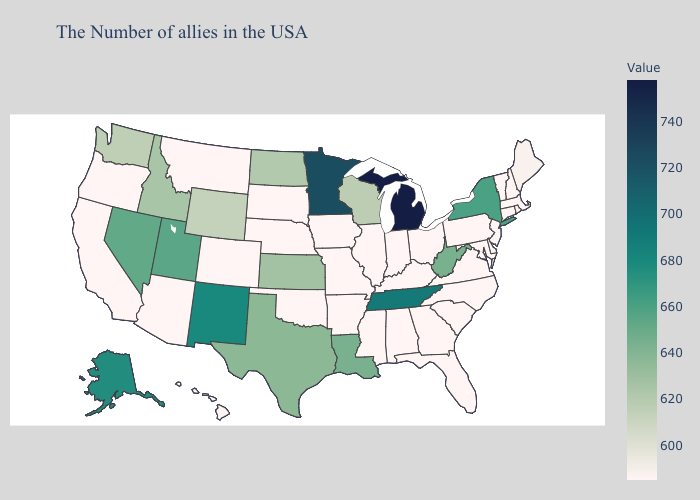Does Oregon have the lowest value in the USA?
Quick response, please. Yes. Does Tennessee have the highest value in the USA?
Give a very brief answer. No. Among the states that border Nevada , does Idaho have the highest value?
Concise answer only. No. Does Michigan have the highest value in the MidWest?
Concise answer only. Yes. Which states have the lowest value in the West?
Quick response, please. Colorado, Montana, Arizona, California, Oregon, Hawaii. Does Michigan have the highest value in the USA?
Give a very brief answer. Yes. Does Connecticut have the lowest value in the USA?
Give a very brief answer. Yes. Does West Virginia have the highest value in the South?
Short answer required. No. 